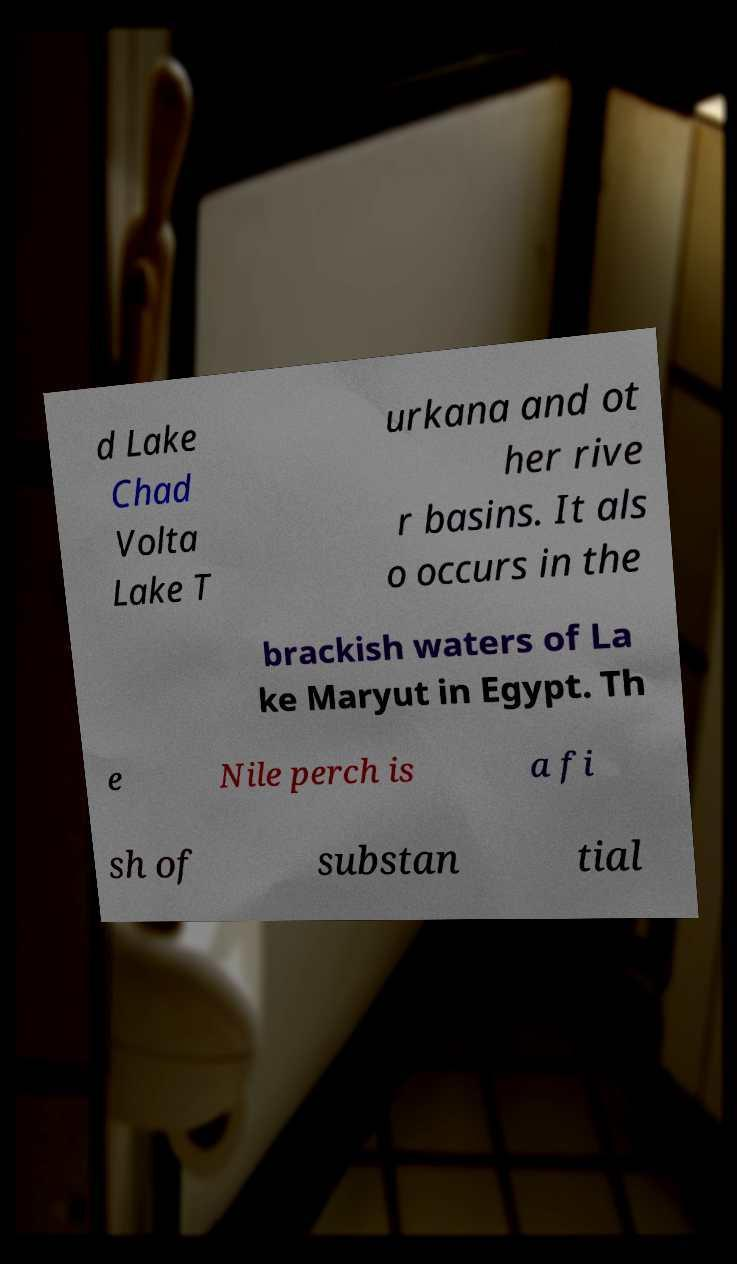Can you accurately transcribe the text from the provided image for me? d Lake Chad Volta Lake T urkana and ot her rive r basins. It als o occurs in the brackish waters of La ke Maryut in Egypt. Th e Nile perch is a fi sh of substan tial 